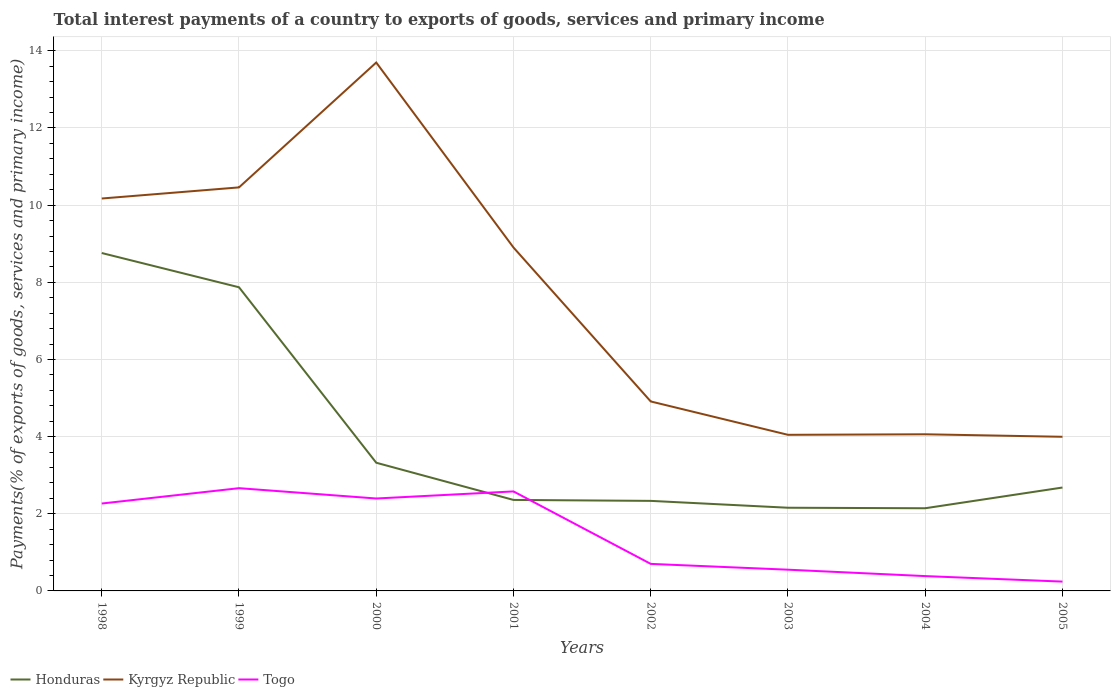How many different coloured lines are there?
Provide a succinct answer. 3. Is the number of lines equal to the number of legend labels?
Provide a succinct answer. Yes. Across all years, what is the maximum total interest payments in Kyrgyz Republic?
Make the answer very short. 4. What is the total total interest payments in Honduras in the graph?
Your answer should be very brief. 0.19. What is the difference between the highest and the second highest total interest payments in Kyrgyz Republic?
Your answer should be compact. 9.7. What is the difference between the highest and the lowest total interest payments in Kyrgyz Republic?
Keep it short and to the point. 4. How many years are there in the graph?
Provide a short and direct response. 8. Are the values on the major ticks of Y-axis written in scientific E-notation?
Make the answer very short. No. Where does the legend appear in the graph?
Give a very brief answer. Bottom left. What is the title of the graph?
Give a very brief answer. Total interest payments of a country to exports of goods, services and primary income. What is the label or title of the X-axis?
Your response must be concise. Years. What is the label or title of the Y-axis?
Your answer should be very brief. Payments(% of exports of goods, services and primary income). What is the Payments(% of exports of goods, services and primary income) of Honduras in 1998?
Your answer should be compact. 8.76. What is the Payments(% of exports of goods, services and primary income) of Kyrgyz Republic in 1998?
Provide a short and direct response. 10.17. What is the Payments(% of exports of goods, services and primary income) of Togo in 1998?
Your answer should be very brief. 2.27. What is the Payments(% of exports of goods, services and primary income) in Honduras in 1999?
Your answer should be very brief. 7.87. What is the Payments(% of exports of goods, services and primary income) of Kyrgyz Republic in 1999?
Your answer should be compact. 10.46. What is the Payments(% of exports of goods, services and primary income) of Togo in 1999?
Keep it short and to the point. 2.66. What is the Payments(% of exports of goods, services and primary income) in Honduras in 2000?
Offer a terse response. 3.32. What is the Payments(% of exports of goods, services and primary income) in Kyrgyz Republic in 2000?
Provide a short and direct response. 13.7. What is the Payments(% of exports of goods, services and primary income) of Togo in 2000?
Make the answer very short. 2.4. What is the Payments(% of exports of goods, services and primary income) of Honduras in 2001?
Your response must be concise. 2.36. What is the Payments(% of exports of goods, services and primary income) of Kyrgyz Republic in 2001?
Make the answer very short. 8.9. What is the Payments(% of exports of goods, services and primary income) of Togo in 2001?
Make the answer very short. 2.58. What is the Payments(% of exports of goods, services and primary income) in Honduras in 2002?
Offer a terse response. 2.33. What is the Payments(% of exports of goods, services and primary income) in Kyrgyz Republic in 2002?
Your response must be concise. 4.91. What is the Payments(% of exports of goods, services and primary income) of Togo in 2002?
Provide a short and direct response. 0.7. What is the Payments(% of exports of goods, services and primary income) in Honduras in 2003?
Offer a terse response. 2.16. What is the Payments(% of exports of goods, services and primary income) of Kyrgyz Republic in 2003?
Keep it short and to the point. 4.05. What is the Payments(% of exports of goods, services and primary income) of Togo in 2003?
Offer a very short reply. 0.55. What is the Payments(% of exports of goods, services and primary income) in Honduras in 2004?
Provide a succinct answer. 2.14. What is the Payments(% of exports of goods, services and primary income) in Kyrgyz Republic in 2004?
Offer a very short reply. 4.06. What is the Payments(% of exports of goods, services and primary income) of Togo in 2004?
Make the answer very short. 0.38. What is the Payments(% of exports of goods, services and primary income) in Honduras in 2005?
Make the answer very short. 2.68. What is the Payments(% of exports of goods, services and primary income) in Kyrgyz Republic in 2005?
Your answer should be very brief. 4. What is the Payments(% of exports of goods, services and primary income) of Togo in 2005?
Provide a succinct answer. 0.24. Across all years, what is the maximum Payments(% of exports of goods, services and primary income) of Honduras?
Provide a short and direct response. 8.76. Across all years, what is the maximum Payments(% of exports of goods, services and primary income) of Kyrgyz Republic?
Keep it short and to the point. 13.7. Across all years, what is the maximum Payments(% of exports of goods, services and primary income) in Togo?
Offer a very short reply. 2.66. Across all years, what is the minimum Payments(% of exports of goods, services and primary income) of Honduras?
Give a very brief answer. 2.14. Across all years, what is the minimum Payments(% of exports of goods, services and primary income) in Kyrgyz Republic?
Make the answer very short. 4. Across all years, what is the minimum Payments(% of exports of goods, services and primary income) in Togo?
Offer a very short reply. 0.24. What is the total Payments(% of exports of goods, services and primary income) of Honduras in the graph?
Offer a very short reply. 31.63. What is the total Payments(% of exports of goods, services and primary income) in Kyrgyz Republic in the graph?
Ensure brevity in your answer.  60.25. What is the total Payments(% of exports of goods, services and primary income) of Togo in the graph?
Your answer should be very brief. 11.78. What is the difference between the Payments(% of exports of goods, services and primary income) of Honduras in 1998 and that in 1999?
Your answer should be very brief. 0.89. What is the difference between the Payments(% of exports of goods, services and primary income) in Kyrgyz Republic in 1998 and that in 1999?
Your response must be concise. -0.29. What is the difference between the Payments(% of exports of goods, services and primary income) of Togo in 1998 and that in 1999?
Provide a succinct answer. -0.4. What is the difference between the Payments(% of exports of goods, services and primary income) of Honduras in 1998 and that in 2000?
Your answer should be compact. 5.44. What is the difference between the Payments(% of exports of goods, services and primary income) of Kyrgyz Republic in 1998 and that in 2000?
Your answer should be very brief. -3.52. What is the difference between the Payments(% of exports of goods, services and primary income) in Togo in 1998 and that in 2000?
Offer a terse response. -0.13. What is the difference between the Payments(% of exports of goods, services and primary income) in Honduras in 1998 and that in 2001?
Your answer should be compact. 6.4. What is the difference between the Payments(% of exports of goods, services and primary income) of Kyrgyz Republic in 1998 and that in 2001?
Your answer should be very brief. 1.27. What is the difference between the Payments(% of exports of goods, services and primary income) of Togo in 1998 and that in 2001?
Make the answer very short. -0.31. What is the difference between the Payments(% of exports of goods, services and primary income) in Honduras in 1998 and that in 2002?
Give a very brief answer. 6.43. What is the difference between the Payments(% of exports of goods, services and primary income) of Kyrgyz Republic in 1998 and that in 2002?
Your answer should be very brief. 5.26. What is the difference between the Payments(% of exports of goods, services and primary income) of Togo in 1998 and that in 2002?
Your answer should be compact. 1.56. What is the difference between the Payments(% of exports of goods, services and primary income) in Honduras in 1998 and that in 2003?
Offer a very short reply. 6.6. What is the difference between the Payments(% of exports of goods, services and primary income) in Kyrgyz Republic in 1998 and that in 2003?
Offer a terse response. 6.13. What is the difference between the Payments(% of exports of goods, services and primary income) in Togo in 1998 and that in 2003?
Your answer should be compact. 1.71. What is the difference between the Payments(% of exports of goods, services and primary income) of Honduras in 1998 and that in 2004?
Keep it short and to the point. 6.62. What is the difference between the Payments(% of exports of goods, services and primary income) in Kyrgyz Republic in 1998 and that in 2004?
Give a very brief answer. 6.11. What is the difference between the Payments(% of exports of goods, services and primary income) of Togo in 1998 and that in 2004?
Provide a short and direct response. 1.88. What is the difference between the Payments(% of exports of goods, services and primary income) of Honduras in 1998 and that in 2005?
Make the answer very short. 6.08. What is the difference between the Payments(% of exports of goods, services and primary income) of Kyrgyz Republic in 1998 and that in 2005?
Provide a short and direct response. 6.18. What is the difference between the Payments(% of exports of goods, services and primary income) of Togo in 1998 and that in 2005?
Provide a short and direct response. 2.02. What is the difference between the Payments(% of exports of goods, services and primary income) of Honduras in 1999 and that in 2000?
Ensure brevity in your answer.  4.55. What is the difference between the Payments(% of exports of goods, services and primary income) of Kyrgyz Republic in 1999 and that in 2000?
Give a very brief answer. -3.24. What is the difference between the Payments(% of exports of goods, services and primary income) of Togo in 1999 and that in 2000?
Your response must be concise. 0.27. What is the difference between the Payments(% of exports of goods, services and primary income) in Honduras in 1999 and that in 2001?
Offer a terse response. 5.51. What is the difference between the Payments(% of exports of goods, services and primary income) in Kyrgyz Republic in 1999 and that in 2001?
Keep it short and to the point. 1.56. What is the difference between the Payments(% of exports of goods, services and primary income) of Togo in 1999 and that in 2001?
Give a very brief answer. 0.08. What is the difference between the Payments(% of exports of goods, services and primary income) in Honduras in 1999 and that in 2002?
Your answer should be compact. 5.54. What is the difference between the Payments(% of exports of goods, services and primary income) of Kyrgyz Republic in 1999 and that in 2002?
Offer a very short reply. 5.55. What is the difference between the Payments(% of exports of goods, services and primary income) in Togo in 1999 and that in 2002?
Your answer should be very brief. 1.96. What is the difference between the Payments(% of exports of goods, services and primary income) in Honduras in 1999 and that in 2003?
Your response must be concise. 5.71. What is the difference between the Payments(% of exports of goods, services and primary income) of Kyrgyz Republic in 1999 and that in 2003?
Make the answer very short. 6.41. What is the difference between the Payments(% of exports of goods, services and primary income) in Togo in 1999 and that in 2003?
Offer a very short reply. 2.11. What is the difference between the Payments(% of exports of goods, services and primary income) of Honduras in 1999 and that in 2004?
Ensure brevity in your answer.  5.73. What is the difference between the Payments(% of exports of goods, services and primary income) in Kyrgyz Republic in 1999 and that in 2004?
Your answer should be very brief. 6.4. What is the difference between the Payments(% of exports of goods, services and primary income) in Togo in 1999 and that in 2004?
Offer a terse response. 2.28. What is the difference between the Payments(% of exports of goods, services and primary income) of Honduras in 1999 and that in 2005?
Offer a terse response. 5.19. What is the difference between the Payments(% of exports of goods, services and primary income) in Kyrgyz Republic in 1999 and that in 2005?
Ensure brevity in your answer.  6.46. What is the difference between the Payments(% of exports of goods, services and primary income) of Togo in 1999 and that in 2005?
Your answer should be very brief. 2.42. What is the difference between the Payments(% of exports of goods, services and primary income) of Honduras in 2000 and that in 2001?
Make the answer very short. 0.96. What is the difference between the Payments(% of exports of goods, services and primary income) in Kyrgyz Republic in 2000 and that in 2001?
Keep it short and to the point. 4.79. What is the difference between the Payments(% of exports of goods, services and primary income) of Togo in 2000 and that in 2001?
Offer a very short reply. -0.18. What is the difference between the Payments(% of exports of goods, services and primary income) in Honduras in 2000 and that in 2002?
Ensure brevity in your answer.  0.99. What is the difference between the Payments(% of exports of goods, services and primary income) of Kyrgyz Republic in 2000 and that in 2002?
Give a very brief answer. 8.79. What is the difference between the Payments(% of exports of goods, services and primary income) of Togo in 2000 and that in 2002?
Provide a succinct answer. 1.7. What is the difference between the Payments(% of exports of goods, services and primary income) of Honduras in 2000 and that in 2003?
Offer a terse response. 1.17. What is the difference between the Payments(% of exports of goods, services and primary income) of Kyrgyz Republic in 2000 and that in 2003?
Offer a terse response. 9.65. What is the difference between the Payments(% of exports of goods, services and primary income) in Togo in 2000 and that in 2003?
Give a very brief answer. 1.85. What is the difference between the Payments(% of exports of goods, services and primary income) in Honduras in 2000 and that in 2004?
Keep it short and to the point. 1.18. What is the difference between the Payments(% of exports of goods, services and primary income) in Kyrgyz Republic in 2000 and that in 2004?
Your answer should be very brief. 9.64. What is the difference between the Payments(% of exports of goods, services and primary income) of Togo in 2000 and that in 2004?
Provide a succinct answer. 2.01. What is the difference between the Payments(% of exports of goods, services and primary income) in Honduras in 2000 and that in 2005?
Keep it short and to the point. 0.64. What is the difference between the Payments(% of exports of goods, services and primary income) of Kyrgyz Republic in 2000 and that in 2005?
Your answer should be very brief. 9.7. What is the difference between the Payments(% of exports of goods, services and primary income) of Togo in 2000 and that in 2005?
Make the answer very short. 2.15. What is the difference between the Payments(% of exports of goods, services and primary income) of Honduras in 2001 and that in 2002?
Ensure brevity in your answer.  0.02. What is the difference between the Payments(% of exports of goods, services and primary income) of Kyrgyz Republic in 2001 and that in 2002?
Ensure brevity in your answer.  3.99. What is the difference between the Payments(% of exports of goods, services and primary income) of Togo in 2001 and that in 2002?
Your answer should be compact. 1.88. What is the difference between the Payments(% of exports of goods, services and primary income) of Honduras in 2001 and that in 2003?
Offer a very short reply. 0.2. What is the difference between the Payments(% of exports of goods, services and primary income) in Kyrgyz Republic in 2001 and that in 2003?
Provide a short and direct response. 4.86. What is the difference between the Payments(% of exports of goods, services and primary income) of Togo in 2001 and that in 2003?
Offer a very short reply. 2.03. What is the difference between the Payments(% of exports of goods, services and primary income) of Honduras in 2001 and that in 2004?
Offer a very short reply. 0.22. What is the difference between the Payments(% of exports of goods, services and primary income) of Kyrgyz Republic in 2001 and that in 2004?
Provide a succinct answer. 4.84. What is the difference between the Payments(% of exports of goods, services and primary income) in Togo in 2001 and that in 2004?
Keep it short and to the point. 2.19. What is the difference between the Payments(% of exports of goods, services and primary income) of Honduras in 2001 and that in 2005?
Your answer should be compact. -0.32. What is the difference between the Payments(% of exports of goods, services and primary income) of Kyrgyz Republic in 2001 and that in 2005?
Ensure brevity in your answer.  4.91. What is the difference between the Payments(% of exports of goods, services and primary income) of Togo in 2001 and that in 2005?
Ensure brevity in your answer.  2.34. What is the difference between the Payments(% of exports of goods, services and primary income) in Honduras in 2002 and that in 2003?
Offer a terse response. 0.18. What is the difference between the Payments(% of exports of goods, services and primary income) in Kyrgyz Republic in 2002 and that in 2003?
Give a very brief answer. 0.86. What is the difference between the Payments(% of exports of goods, services and primary income) of Togo in 2002 and that in 2003?
Offer a very short reply. 0.15. What is the difference between the Payments(% of exports of goods, services and primary income) in Honduras in 2002 and that in 2004?
Provide a succinct answer. 0.19. What is the difference between the Payments(% of exports of goods, services and primary income) of Kyrgyz Republic in 2002 and that in 2004?
Your response must be concise. 0.85. What is the difference between the Payments(% of exports of goods, services and primary income) of Togo in 2002 and that in 2004?
Your response must be concise. 0.32. What is the difference between the Payments(% of exports of goods, services and primary income) of Honduras in 2002 and that in 2005?
Provide a succinct answer. -0.35. What is the difference between the Payments(% of exports of goods, services and primary income) of Kyrgyz Republic in 2002 and that in 2005?
Offer a terse response. 0.92. What is the difference between the Payments(% of exports of goods, services and primary income) in Togo in 2002 and that in 2005?
Give a very brief answer. 0.46. What is the difference between the Payments(% of exports of goods, services and primary income) of Honduras in 2003 and that in 2004?
Offer a terse response. 0.01. What is the difference between the Payments(% of exports of goods, services and primary income) of Kyrgyz Republic in 2003 and that in 2004?
Your answer should be compact. -0.01. What is the difference between the Payments(% of exports of goods, services and primary income) of Togo in 2003 and that in 2004?
Offer a very short reply. 0.17. What is the difference between the Payments(% of exports of goods, services and primary income) of Honduras in 2003 and that in 2005?
Your answer should be compact. -0.52. What is the difference between the Payments(% of exports of goods, services and primary income) in Kyrgyz Republic in 2003 and that in 2005?
Keep it short and to the point. 0.05. What is the difference between the Payments(% of exports of goods, services and primary income) in Togo in 2003 and that in 2005?
Your response must be concise. 0.31. What is the difference between the Payments(% of exports of goods, services and primary income) in Honduras in 2004 and that in 2005?
Provide a succinct answer. -0.54. What is the difference between the Payments(% of exports of goods, services and primary income) in Kyrgyz Republic in 2004 and that in 2005?
Provide a succinct answer. 0.06. What is the difference between the Payments(% of exports of goods, services and primary income) of Togo in 2004 and that in 2005?
Provide a succinct answer. 0.14. What is the difference between the Payments(% of exports of goods, services and primary income) in Honduras in 1998 and the Payments(% of exports of goods, services and primary income) in Kyrgyz Republic in 1999?
Offer a terse response. -1.7. What is the difference between the Payments(% of exports of goods, services and primary income) of Honduras in 1998 and the Payments(% of exports of goods, services and primary income) of Togo in 1999?
Your answer should be compact. 6.1. What is the difference between the Payments(% of exports of goods, services and primary income) in Kyrgyz Republic in 1998 and the Payments(% of exports of goods, services and primary income) in Togo in 1999?
Give a very brief answer. 7.51. What is the difference between the Payments(% of exports of goods, services and primary income) in Honduras in 1998 and the Payments(% of exports of goods, services and primary income) in Kyrgyz Republic in 2000?
Your answer should be compact. -4.94. What is the difference between the Payments(% of exports of goods, services and primary income) in Honduras in 1998 and the Payments(% of exports of goods, services and primary income) in Togo in 2000?
Provide a short and direct response. 6.36. What is the difference between the Payments(% of exports of goods, services and primary income) of Kyrgyz Republic in 1998 and the Payments(% of exports of goods, services and primary income) of Togo in 2000?
Ensure brevity in your answer.  7.78. What is the difference between the Payments(% of exports of goods, services and primary income) in Honduras in 1998 and the Payments(% of exports of goods, services and primary income) in Kyrgyz Republic in 2001?
Your answer should be compact. -0.14. What is the difference between the Payments(% of exports of goods, services and primary income) of Honduras in 1998 and the Payments(% of exports of goods, services and primary income) of Togo in 2001?
Keep it short and to the point. 6.18. What is the difference between the Payments(% of exports of goods, services and primary income) of Kyrgyz Republic in 1998 and the Payments(% of exports of goods, services and primary income) of Togo in 2001?
Offer a terse response. 7.59. What is the difference between the Payments(% of exports of goods, services and primary income) of Honduras in 1998 and the Payments(% of exports of goods, services and primary income) of Kyrgyz Republic in 2002?
Offer a terse response. 3.85. What is the difference between the Payments(% of exports of goods, services and primary income) of Honduras in 1998 and the Payments(% of exports of goods, services and primary income) of Togo in 2002?
Your answer should be compact. 8.06. What is the difference between the Payments(% of exports of goods, services and primary income) in Kyrgyz Republic in 1998 and the Payments(% of exports of goods, services and primary income) in Togo in 2002?
Your answer should be compact. 9.47. What is the difference between the Payments(% of exports of goods, services and primary income) in Honduras in 1998 and the Payments(% of exports of goods, services and primary income) in Kyrgyz Republic in 2003?
Your response must be concise. 4.71. What is the difference between the Payments(% of exports of goods, services and primary income) in Honduras in 1998 and the Payments(% of exports of goods, services and primary income) in Togo in 2003?
Offer a very short reply. 8.21. What is the difference between the Payments(% of exports of goods, services and primary income) in Kyrgyz Republic in 1998 and the Payments(% of exports of goods, services and primary income) in Togo in 2003?
Your answer should be compact. 9.62. What is the difference between the Payments(% of exports of goods, services and primary income) in Honduras in 1998 and the Payments(% of exports of goods, services and primary income) in Kyrgyz Republic in 2004?
Ensure brevity in your answer.  4.7. What is the difference between the Payments(% of exports of goods, services and primary income) in Honduras in 1998 and the Payments(% of exports of goods, services and primary income) in Togo in 2004?
Offer a terse response. 8.37. What is the difference between the Payments(% of exports of goods, services and primary income) in Kyrgyz Republic in 1998 and the Payments(% of exports of goods, services and primary income) in Togo in 2004?
Your response must be concise. 9.79. What is the difference between the Payments(% of exports of goods, services and primary income) in Honduras in 1998 and the Payments(% of exports of goods, services and primary income) in Kyrgyz Republic in 2005?
Your answer should be very brief. 4.76. What is the difference between the Payments(% of exports of goods, services and primary income) in Honduras in 1998 and the Payments(% of exports of goods, services and primary income) in Togo in 2005?
Your answer should be very brief. 8.52. What is the difference between the Payments(% of exports of goods, services and primary income) of Kyrgyz Republic in 1998 and the Payments(% of exports of goods, services and primary income) of Togo in 2005?
Offer a very short reply. 9.93. What is the difference between the Payments(% of exports of goods, services and primary income) of Honduras in 1999 and the Payments(% of exports of goods, services and primary income) of Kyrgyz Republic in 2000?
Your answer should be compact. -5.83. What is the difference between the Payments(% of exports of goods, services and primary income) in Honduras in 1999 and the Payments(% of exports of goods, services and primary income) in Togo in 2000?
Give a very brief answer. 5.48. What is the difference between the Payments(% of exports of goods, services and primary income) in Kyrgyz Republic in 1999 and the Payments(% of exports of goods, services and primary income) in Togo in 2000?
Offer a very short reply. 8.06. What is the difference between the Payments(% of exports of goods, services and primary income) in Honduras in 1999 and the Payments(% of exports of goods, services and primary income) in Kyrgyz Republic in 2001?
Provide a succinct answer. -1.03. What is the difference between the Payments(% of exports of goods, services and primary income) in Honduras in 1999 and the Payments(% of exports of goods, services and primary income) in Togo in 2001?
Keep it short and to the point. 5.29. What is the difference between the Payments(% of exports of goods, services and primary income) of Kyrgyz Republic in 1999 and the Payments(% of exports of goods, services and primary income) of Togo in 2001?
Your answer should be compact. 7.88. What is the difference between the Payments(% of exports of goods, services and primary income) in Honduras in 1999 and the Payments(% of exports of goods, services and primary income) in Kyrgyz Republic in 2002?
Your response must be concise. 2.96. What is the difference between the Payments(% of exports of goods, services and primary income) in Honduras in 1999 and the Payments(% of exports of goods, services and primary income) in Togo in 2002?
Provide a succinct answer. 7.17. What is the difference between the Payments(% of exports of goods, services and primary income) of Kyrgyz Republic in 1999 and the Payments(% of exports of goods, services and primary income) of Togo in 2002?
Ensure brevity in your answer.  9.76. What is the difference between the Payments(% of exports of goods, services and primary income) in Honduras in 1999 and the Payments(% of exports of goods, services and primary income) in Kyrgyz Republic in 2003?
Keep it short and to the point. 3.82. What is the difference between the Payments(% of exports of goods, services and primary income) of Honduras in 1999 and the Payments(% of exports of goods, services and primary income) of Togo in 2003?
Give a very brief answer. 7.32. What is the difference between the Payments(% of exports of goods, services and primary income) of Kyrgyz Republic in 1999 and the Payments(% of exports of goods, services and primary income) of Togo in 2003?
Make the answer very short. 9.91. What is the difference between the Payments(% of exports of goods, services and primary income) in Honduras in 1999 and the Payments(% of exports of goods, services and primary income) in Kyrgyz Republic in 2004?
Keep it short and to the point. 3.81. What is the difference between the Payments(% of exports of goods, services and primary income) in Honduras in 1999 and the Payments(% of exports of goods, services and primary income) in Togo in 2004?
Make the answer very short. 7.49. What is the difference between the Payments(% of exports of goods, services and primary income) of Kyrgyz Republic in 1999 and the Payments(% of exports of goods, services and primary income) of Togo in 2004?
Offer a very short reply. 10.08. What is the difference between the Payments(% of exports of goods, services and primary income) of Honduras in 1999 and the Payments(% of exports of goods, services and primary income) of Kyrgyz Republic in 2005?
Give a very brief answer. 3.88. What is the difference between the Payments(% of exports of goods, services and primary income) in Honduras in 1999 and the Payments(% of exports of goods, services and primary income) in Togo in 2005?
Your answer should be very brief. 7.63. What is the difference between the Payments(% of exports of goods, services and primary income) of Kyrgyz Republic in 1999 and the Payments(% of exports of goods, services and primary income) of Togo in 2005?
Keep it short and to the point. 10.22. What is the difference between the Payments(% of exports of goods, services and primary income) in Honduras in 2000 and the Payments(% of exports of goods, services and primary income) in Kyrgyz Republic in 2001?
Offer a terse response. -5.58. What is the difference between the Payments(% of exports of goods, services and primary income) of Honduras in 2000 and the Payments(% of exports of goods, services and primary income) of Togo in 2001?
Your answer should be compact. 0.74. What is the difference between the Payments(% of exports of goods, services and primary income) of Kyrgyz Republic in 2000 and the Payments(% of exports of goods, services and primary income) of Togo in 2001?
Keep it short and to the point. 11.12. What is the difference between the Payments(% of exports of goods, services and primary income) of Honduras in 2000 and the Payments(% of exports of goods, services and primary income) of Kyrgyz Republic in 2002?
Your answer should be very brief. -1.59. What is the difference between the Payments(% of exports of goods, services and primary income) of Honduras in 2000 and the Payments(% of exports of goods, services and primary income) of Togo in 2002?
Your answer should be very brief. 2.62. What is the difference between the Payments(% of exports of goods, services and primary income) in Kyrgyz Republic in 2000 and the Payments(% of exports of goods, services and primary income) in Togo in 2002?
Keep it short and to the point. 13. What is the difference between the Payments(% of exports of goods, services and primary income) in Honduras in 2000 and the Payments(% of exports of goods, services and primary income) in Kyrgyz Republic in 2003?
Your response must be concise. -0.72. What is the difference between the Payments(% of exports of goods, services and primary income) of Honduras in 2000 and the Payments(% of exports of goods, services and primary income) of Togo in 2003?
Your answer should be compact. 2.77. What is the difference between the Payments(% of exports of goods, services and primary income) of Kyrgyz Republic in 2000 and the Payments(% of exports of goods, services and primary income) of Togo in 2003?
Your answer should be compact. 13.15. What is the difference between the Payments(% of exports of goods, services and primary income) in Honduras in 2000 and the Payments(% of exports of goods, services and primary income) in Kyrgyz Republic in 2004?
Ensure brevity in your answer.  -0.74. What is the difference between the Payments(% of exports of goods, services and primary income) of Honduras in 2000 and the Payments(% of exports of goods, services and primary income) of Togo in 2004?
Your answer should be compact. 2.94. What is the difference between the Payments(% of exports of goods, services and primary income) in Kyrgyz Republic in 2000 and the Payments(% of exports of goods, services and primary income) in Togo in 2004?
Provide a succinct answer. 13.31. What is the difference between the Payments(% of exports of goods, services and primary income) of Honduras in 2000 and the Payments(% of exports of goods, services and primary income) of Kyrgyz Republic in 2005?
Make the answer very short. -0.67. What is the difference between the Payments(% of exports of goods, services and primary income) in Honduras in 2000 and the Payments(% of exports of goods, services and primary income) in Togo in 2005?
Provide a short and direct response. 3.08. What is the difference between the Payments(% of exports of goods, services and primary income) of Kyrgyz Republic in 2000 and the Payments(% of exports of goods, services and primary income) of Togo in 2005?
Give a very brief answer. 13.46. What is the difference between the Payments(% of exports of goods, services and primary income) in Honduras in 2001 and the Payments(% of exports of goods, services and primary income) in Kyrgyz Republic in 2002?
Ensure brevity in your answer.  -2.55. What is the difference between the Payments(% of exports of goods, services and primary income) in Honduras in 2001 and the Payments(% of exports of goods, services and primary income) in Togo in 2002?
Provide a short and direct response. 1.66. What is the difference between the Payments(% of exports of goods, services and primary income) in Kyrgyz Republic in 2001 and the Payments(% of exports of goods, services and primary income) in Togo in 2002?
Your answer should be very brief. 8.2. What is the difference between the Payments(% of exports of goods, services and primary income) of Honduras in 2001 and the Payments(% of exports of goods, services and primary income) of Kyrgyz Republic in 2003?
Give a very brief answer. -1.69. What is the difference between the Payments(% of exports of goods, services and primary income) of Honduras in 2001 and the Payments(% of exports of goods, services and primary income) of Togo in 2003?
Provide a short and direct response. 1.81. What is the difference between the Payments(% of exports of goods, services and primary income) in Kyrgyz Republic in 2001 and the Payments(% of exports of goods, services and primary income) in Togo in 2003?
Ensure brevity in your answer.  8.35. What is the difference between the Payments(% of exports of goods, services and primary income) of Honduras in 2001 and the Payments(% of exports of goods, services and primary income) of Kyrgyz Republic in 2004?
Provide a short and direct response. -1.7. What is the difference between the Payments(% of exports of goods, services and primary income) in Honduras in 2001 and the Payments(% of exports of goods, services and primary income) in Togo in 2004?
Your answer should be very brief. 1.97. What is the difference between the Payments(% of exports of goods, services and primary income) in Kyrgyz Republic in 2001 and the Payments(% of exports of goods, services and primary income) in Togo in 2004?
Your response must be concise. 8.52. What is the difference between the Payments(% of exports of goods, services and primary income) in Honduras in 2001 and the Payments(% of exports of goods, services and primary income) in Kyrgyz Republic in 2005?
Give a very brief answer. -1.64. What is the difference between the Payments(% of exports of goods, services and primary income) in Honduras in 2001 and the Payments(% of exports of goods, services and primary income) in Togo in 2005?
Your answer should be compact. 2.12. What is the difference between the Payments(% of exports of goods, services and primary income) of Kyrgyz Republic in 2001 and the Payments(% of exports of goods, services and primary income) of Togo in 2005?
Your answer should be very brief. 8.66. What is the difference between the Payments(% of exports of goods, services and primary income) of Honduras in 2002 and the Payments(% of exports of goods, services and primary income) of Kyrgyz Republic in 2003?
Your answer should be very brief. -1.71. What is the difference between the Payments(% of exports of goods, services and primary income) of Honduras in 2002 and the Payments(% of exports of goods, services and primary income) of Togo in 2003?
Keep it short and to the point. 1.78. What is the difference between the Payments(% of exports of goods, services and primary income) in Kyrgyz Republic in 2002 and the Payments(% of exports of goods, services and primary income) in Togo in 2003?
Provide a short and direct response. 4.36. What is the difference between the Payments(% of exports of goods, services and primary income) in Honduras in 2002 and the Payments(% of exports of goods, services and primary income) in Kyrgyz Republic in 2004?
Keep it short and to the point. -1.73. What is the difference between the Payments(% of exports of goods, services and primary income) in Honduras in 2002 and the Payments(% of exports of goods, services and primary income) in Togo in 2004?
Keep it short and to the point. 1.95. What is the difference between the Payments(% of exports of goods, services and primary income) in Kyrgyz Republic in 2002 and the Payments(% of exports of goods, services and primary income) in Togo in 2004?
Your response must be concise. 4.53. What is the difference between the Payments(% of exports of goods, services and primary income) in Honduras in 2002 and the Payments(% of exports of goods, services and primary income) in Kyrgyz Republic in 2005?
Offer a terse response. -1.66. What is the difference between the Payments(% of exports of goods, services and primary income) of Honduras in 2002 and the Payments(% of exports of goods, services and primary income) of Togo in 2005?
Provide a succinct answer. 2.09. What is the difference between the Payments(% of exports of goods, services and primary income) in Kyrgyz Republic in 2002 and the Payments(% of exports of goods, services and primary income) in Togo in 2005?
Your response must be concise. 4.67. What is the difference between the Payments(% of exports of goods, services and primary income) of Honduras in 2003 and the Payments(% of exports of goods, services and primary income) of Kyrgyz Republic in 2004?
Make the answer very short. -1.9. What is the difference between the Payments(% of exports of goods, services and primary income) in Honduras in 2003 and the Payments(% of exports of goods, services and primary income) in Togo in 2004?
Provide a succinct answer. 1.77. What is the difference between the Payments(% of exports of goods, services and primary income) in Kyrgyz Republic in 2003 and the Payments(% of exports of goods, services and primary income) in Togo in 2004?
Give a very brief answer. 3.66. What is the difference between the Payments(% of exports of goods, services and primary income) of Honduras in 2003 and the Payments(% of exports of goods, services and primary income) of Kyrgyz Republic in 2005?
Your answer should be compact. -1.84. What is the difference between the Payments(% of exports of goods, services and primary income) in Honduras in 2003 and the Payments(% of exports of goods, services and primary income) in Togo in 2005?
Offer a terse response. 1.91. What is the difference between the Payments(% of exports of goods, services and primary income) in Kyrgyz Republic in 2003 and the Payments(% of exports of goods, services and primary income) in Togo in 2005?
Give a very brief answer. 3.8. What is the difference between the Payments(% of exports of goods, services and primary income) in Honduras in 2004 and the Payments(% of exports of goods, services and primary income) in Kyrgyz Republic in 2005?
Offer a very short reply. -1.85. What is the difference between the Payments(% of exports of goods, services and primary income) of Honduras in 2004 and the Payments(% of exports of goods, services and primary income) of Togo in 2005?
Offer a terse response. 1.9. What is the difference between the Payments(% of exports of goods, services and primary income) of Kyrgyz Republic in 2004 and the Payments(% of exports of goods, services and primary income) of Togo in 2005?
Your response must be concise. 3.82. What is the average Payments(% of exports of goods, services and primary income) in Honduras per year?
Provide a short and direct response. 3.95. What is the average Payments(% of exports of goods, services and primary income) of Kyrgyz Republic per year?
Make the answer very short. 7.53. What is the average Payments(% of exports of goods, services and primary income) of Togo per year?
Provide a short and direct response. 1.47. In the year 1998, what is the difference between the Payments(% of exports of goods, services and primary income) of Honduras and Payments(% of exports of goods, services and primary income) of Kyrgyz Republic?
Make the answer very short. -1.41. In the year 1998, what is the difference between the Payments(% of exports of goods, services and primary income) in Honduras and Payments(% of exports of goods, services and primary income) in Togo?
Make the answer very short. 6.49. In the year 1998, what is the difference between the Payments(% of exports of goods, services and primary income) in Kyrgyz Republic and Payments(% of exports of goods, services and primary income) in Togo?
Offer a terse response. 7.91. In the year 1999, what is the difference between the Payments(% of exports of goods, services and primary income) in Honduras and Payments(% of exports of goods, services and primary income) in Kyrgyz Republic?
Provide a short and direct response. -2.59. In the year 1999, what is the difference between the Payments(% of exports of goods, services and primary income) in Honduras and Payments(% of exports of goods, services and primary income) in Togo?
Make the answer very short. 5.21. In the year 1999, what is the difference between the Payments(% of exports of goods, services and primary income) of Kyrgyz Republic and Payments(% of exports of goods, services and primary income) of Togo?
Offer a terse response. 7.8. In the year 2000, what is the difference between the Payments(% of exports of goods, services and primary income) of Honduras and Payments(% of exports of goods, services and primary income) of Kyrgyz Republic?
Your answer should be very brief. -10.37. In the year 2000, what is the difference between the Payments(% of exports of goods, services and primary income) of Honduras and Payments(% of exports of goods, services and primary income) of Togo?
Offer a terse response. 0.93. In the year 2000, what is the difference between the Payments(% of exports of goods, services and primary income) of Kyrgyz Republic and Payments(% of exports of goods, services and primary income) of Togo?
Your answer should be very brief. 11.3. In the year 2001, what is the difference between the Payments(% of exports of goods, services and primary income) in Honduras and Payments(% of exports of goods, services and primary income) in Kyrgyz Republic?
Your response must be concise. -6.54. In the year 2001, what is the difference between the Payments(% of exports of goods, services and primary income) of Honduras and Payments(% of exports of goods, services and primary income) of Togo?
Offer a very short reply. -0.22. In the year 2001, what is the difference between the Payments(% of exports of goods, services and primary income) in Kyrgyz Republic and Payments(% of exports of goods, services and primary income) in Togo?
Offer a very short reply. 6.32. In the year 2002, what is the difference between the Payments(% of exports of goods, services and primary income) of Honduras and Payments(% of exports of goods, services and primary income) of Kyrgyz Republic?
Your response must be concise. -2.58. In the year 2002, what is the difference between the Payments(% of exports of goods, services and primary income) in Honduras and Payments(% of exports of goods, services and primary income) in Togo?
Offer a very short reply. 1.63. In the year 2002, what is the difference between the Payments(% of exports of goods, services and primary income) in Kyrgyz Republic and Payments(% of exports of goods, services and primary income) in Togo?
Offer a terse response. 4.21. In the year 2003, what is the difference between the Payments(% of exports of goods, services and primary income) of Honduras and Payments(% of exports of goods, services and primary income) of Kyrgyz Republic?
Your response must be concise. -1.89. In the year 2003, what is the difference between the Payments(% of exports of goods, services and primary income) of Honduras and Payments(% of exports of goods, services and primary income) of Togo?
Keep it short and to the point. 1.61. In the year 2003, what is the difference between the Payments(% of exports of goods, services and primary income) of Kyrgyz Republic and Payments(% of exports of goods, services and primary income) of Togo?
Your response must be concise. 3.5. In the year 2004, what is the difference between the Payments(% of exports of goods, services and primary income) in Honduras and Payments(% of exports of goods, services and primary income) in Kyrgyz Republic?
Keep it short and to the point. -1.92. In the year 2004, what is the difference between the Payments(% of exports of goods, services and primary income) of Honduras and Payments(% of exports of goods, services and primary income) of Togo?
Keep it short and to the point. 1.76. In the year 2004, what is the difference between the Payments(% of exports of goods, services and primary income) in Kyrgyz Republic and Payments(% of exports of goods, services and primary income) in Togo?
Offer a terse response. 3.68. In the year 2005, what is the difference between the Payments(% of exports of goods, services and primary income) of Honduras and Payments(% of exports of goods, services and primary income) of Kyrgyz Republic?
Your response must be concise. -1.32. In the year 2005, what is the difference between the Payments(% of exports of goods, services and primary income) in Honduras and Payments(% of exports of goods, services and primary income) in Togo?
Your response must be concise. 2.44. In the year 2005, what is the difference between the Payments(% of exports of goods, services and primary income) of Kyrgyz Republic and Payments(% of exports of goods, services and primary income) of Togo?
Your answer should be very brief. 3.75. What is the ratio of the Payments(% of exports of goods, services and primary income) of Honduras in 1998 to that in 1999?
Offer a very short reply. 1.11. What is the ratio of the Payments(% of exports of goods, services and primary income) in Kyrgyz Republic in 1998 to that in 1999?
Keep it short and to the point. 0.97. What is the ratio of the Payments(% of exports of goods, services and primary income) of Togo in 1998 to that in 1999?
Provide a succinct answer. 0.85. What is the ratio of the Payments(% of exports of goods, services and primary income) in Honduras in 1998 to that in 2000?
Keep it short and to the point. 2.64. What is the ratio of the Payments(% of exports of goods, services and primary income) of Kyrgyz Republic in 1998 to that in 2000?
Your response must be concise. 0.74. What is the ratio of the Payments(% of exports of goods, services and primary income) of Togo in 1998 to that in 2000?
Your response must be concise. 0.95. What is the ratio of the Payments(% of exports of goods, services and primary income) in Honduras in 1998 to that in 2001?
Provide a short and direct response. 3.71. What is the ratio of the Payments(% of exports of goods, services and primary income) of Kyrgyz Republic in 1998 to that in 2001?
Offer a very short reply. 1.14. What is the ratio of the Payments(% of exports of goods, services and primary income) of Togo in 1998 to that in 2001?
Ensure brevity in your answer.  0.88. What is the ratio of the Payments(% of exports of goods, services and primary income) of Honduras in 1998 to that in 2002?
Provide a short and direct response. 3.75. What is the ratio of the Payments(% of exports of goods, services and primary income) in Kyrgyz Republic in 1998 to that in 2002?
Your answer should be compact. 2.07. What is the ratio of the Payments(% of exports of goods, services and primary income) of Togo in 1998 to that in 2002?
Give a very brief answer. 3.23. What is the ratio of the Payments(% of exports of goods, services and primary income) in Honduras in 1998 to that in 2003?
Give a very brief answer. 4.06. What is the ratio of the Payments(% of exports of goods, services and primary income) of Kyrgyz Republic in 1998 to that in 2003?
Your response must be concise. 2.51. What is the ratio of the Payments(% of exports of goods, services and primary income) in Togo in 1998 to that in 2003?
Provide a short and direct response. 4.12. What is the ratio of the Payments(% of exports of goods, services and primary income) of Honduras in 1998 to that in 2004?
Offer a terse response. 4.09. What is the ratio of the Payments(% of exports of goods, services and primary income) of Kyrgyz Republic in 1998 to that in 2004?
Offer a terse response. 2.51. What is the ratio of the Payments(% of exports of goods, services and primary income) in Togo in 1998 to that in 2004?
Give a very brief answer. 5.89. What is the ratio of the Payments(% of exports of goods, services and primary income) of Honduras in 1998 to that in 2005?
Your answer should be very brief. 3.27. What is the ratio of the Payments(% of exports of goods, services and primary income) in Kyrgyz Republic in 1998 to that in 2005?
Your answer should be compact. 2.55. What is the ratio of the Payments(% of exports of goods, services and primary income) of Togo in 1998 to that in 2005?
Offer a very short reply. 9.37. What is the ratio of the Payments(% of exports of goods, services and primary income) in Honduras in 1999 to that in 2000?
Provide a succinct answer. 2.37. What is the ratio of the Payments(% of exports of goods, services and primary income) of Kyrgyz Republic in 1999 to that in 2000?
Ensure brevity in your answer.  0.76. What is the ratio of the Payments(% of exports of goods, services and primary income) in Togo in 1999 to that in 2000?
Your answer should be compact. 1.11. What is the ratio of the Payments(% of exports of goods, services and primary income) of Honduras in 1999 to that in 2001?
Your response must be concise. 3.34. What is the ratio of the Payments(% of exports of goods, services and primary income) in Kyrgyz Republic in 1999 to that in 2001?
Your answer should be compact. 1.18. What is the ratio of the Payments(% of exports of goods, services and primary income) of Togo in 1999 to that in 2001?
Your answer should be compact. 1.03. What is the ratio of the Payments(% of exports of goods, services and primary income) in Honduras in 1999 to that in 2002?
Provide a succinct answer. 3.37. What is the ratio of the Payments(% of exports of goods, services and primary income) of Kyrgyz Republic in 1999 to that in 2002?
Your answer should be very brief. 2.13. What is the ratio of the Payments(% of exports of goods, services and primary income) in Togo in 1999 to that in 2002?
Your answer should be compact. 3.8. What is the ratio of the Payments(% of exports of goods, services and primary income) in Honduras in 1999 to that in 2003?
Your answer should be compact. 3.65. What is the ratio of the Payments(% of exports of goods, services and primary income) in Kyrgyz Republic in 1999 to that in 2003?
Keep it short and to the point. 2.58. What is the ratio of the Payments(% of exports of goods, services and primary income) in Togo in 1999 to that in 2003?
Make the answer very short. 4.84. What is the ratio of the Payments(% of exports of goods, services and primary income) in Honduras in 1999 to that in 2004?
Provide a succinct answer. 3.67. What is the ratio of the Payments(% of exports of goods, services and primary income) in Kyrgyz Republic in 1999 to that in 2004?
Give a very brief answer. 2.58. What is the ratio of the Payments(% of exports of goods, services and primary income) of Togo in 1999 to that in 2004?
Offer a terse response. 6.93. What is the ratio of the Payments(% of exports of goods, services and primary income) of Honduras in 1999 to that in 2005?
Your response must be concise. 2.94. What is the ratio of the Payments(% of exports of goods, services and primary income) of Kyrgyz Republic in 1999 to that in 2005?
Offer a terse response. 2.62. What is the ratio of the Payments(% of exports of goods, services and primary income) in Togo in 1999 to that in 2005?
Provide a short and direct response. 11.02. What is the ratio of the Payments(% of exports of goods, services and primary income) of Honduras in 2000 to that in 2001?
Ensure brevity in your answer.  1.41. What is the ratio of the Payments(% of exports of goods, services and primary income) of Kyrgyz Republic in 2000 to that in 2001?
Offer a terse response. 1.54. What is the ratio of the Payments(% of exports of goods, services and primary income) of Togo in 2000 to that in 2001?
Give a very brief answer. 0.93. What is the ratio of the Payments(% of exports of goods, services and primary income) in Honduras in 2000 to that in 2002?
Ensure brevity in your answer.  1.42. What is the ratio of the Payments(% of exports of goods, services and primary income) of Kyrgyz Republic in 2000 to that in 2002?
Your answer should be compact. 2.79. What is the ratio of the Payments(% of exports of goods, services and primary income) of Togo in 2000 to that in 2002?
Your response must be concise. 3.42. What is the ratio of the Payments(% of exports of goods, services and primary income) of Honduras in 2000 to that in 2003?
Your answer should be compact. 1.54. What is the ratio of the Payments(% of exports of goods, services and primary income) of Kyrgyz Republic in 2000 to that in 2003?
Offer a very short reply. 3.38. What is the ratio of the Payments(% of exports of goods, services and primary income) in Togo in 2000 to that in 2003?
Make the answer very short. 4.35. What is the ratio of the Payments(% of exports of goods, services and primary income) in Honduras in 2000 to that in 2004?
Your answer should be compact. 1.55. What is the ratio of the Payments(% of exports of goods, services and primary income) in Kyrgyz Republic in 2000 to that in 2004?
Your response must be concise. 3.37. What is the ratio of the Payments(% of exports of goods, services and primary income) in Togo in 2000 to that in 2004?
Your answer should be compact. 6.23. What is the ratio of the Payments(% of exports of goods, services and primary income) of Honduras in 2000 to that in 2005?
Make the answer very short. 1.24. What is the ratio of the Payments(% of exports of goods, services and primary income) of Kyrgyz Republic in 2000 to that in 2005?
Your answer should be compact. 3.43. What is the ratio of the Payments(% of exports of goods, services and primary income) in Togo in 2000 to that in 2005?
Ensure brevity in your answer.  9.91. What is the ratio of the Payments(% of exports of goods, services and primary income) of Honduras in 2001 to that in 2002?
Your answer should be compact. 1.01. What is the ratio of the Payments(% of exports of goods, services and primary income) of Kyrgyz Republic in 2001 to that in 2002?
Your response must be concise. 1.81. What is the ratio of the Payments(% of exports of goods, services and primary income) of Togo in 2001 to that in 2002?
Provide a short and direct response. 3.68. What is the ratio of the Payments(% of exports of goods, services and primary income) in Honduras in 2001 to that in 2003?
Give a very brief answer. 1.09. What is the ratio of the Payments(% of exports of goods, services and primary income) in Kyrgyz Republic in 2001 to that in 2003?
Ensure brevity in your answer.  2.2. What is the ratio of the Payments(% of exports of goods, services and primary income) in Togo in 2001 to that in 2003?
Ensure brevity in your answer.  4.69. What is the ratio of the Payments(% of exports of goods, services and primary income) of Honduras in 2001 to that in 2004?
Your answer should be compact. 1.1. What is the ratio of the Payments(% of exports of goods, services and primary income) of Kyrgyz Republic in 2001 to that in 2004?
Make the answer very short. 2.19. What is the ratio of the Payments(% of exports of goods, services and primary income) of Togo in 2001 to that in 2004?
Give a very brief answer. 6.71. What is the ratio of the Payments(% of exports of goods, services and primary income) in Honduras in 2001 to that in 2005?
Keep it short and to the point. 0.88. What is the ratio of the Payments(% of exports of goods, services and primary income) in Kyrgyz Republic in 2001 to that in 2005?
Your answer should be very brief. 2.23. What is the ratio of the Payments(% of exports of goods, services and primary income) of Togo in 2001 to that in 2005?
Give a very brief answer. 10.67. What is the ratio of the Payments(% of exports of goods, services and primary income) in Honduras in 2002 to that in 2003?
Provide a short and direct response. 1.08. What is the ratio of the Payments(% of exports of goods, services and primary income) of Kyrgyz Republic in 2002 to that in 2003?
Your answer should be very brief. 1.21. What is the ratio of the Payments(% of exports of goods, services and primary income) in Togo in 2002 to that in 2003?
Ensure brevity in your answer.  1.27. What is the ratio of the Payments(% of exports of goods, services and primary income) in Honduras in 2002 to that in 2004?
Keep it short and to the point. 1.09. What is the ratio of the Payments(% of exports of goods, services and primary income) in Kyrgyz Republic in 2002 to that in 2004?
Your answer should be very brief. 1.21. What is the ratio of the Payments(% of exports of goods, services and primary income) in Togo in 2002 to that in 2004?
Offer a terse response. 1.82. What is the ratio of the Payments(% of exports of goods, services and primary income) of Honduras in 2002 to that in 2005?
Ensure brevity in your answer.  0.87. What is the ratio of the Payments(% of exports of goods, services and primary income) in Kyrgyz Republic in 2002 to that in 2005?
Your answer should be very brief. 1.23. What is the ratio of the Payments(% of exports of goods, services and primary income) of Kyrgyz Republic in 2003 to that in 2004?
Your answer should be very brief. 1. What is the ratio of the Payments(% of exports of goods, services and primary income) in Togo in 2003 to that in 2004?
Provide a succinct answer. 1.43. What is the ratio of the Payments(% of exports of goods, services and primary income) of Honduras in 2003 to that in 2005?
Offer a terse response. 0.8. What is the ratio of the Payments(% of exports of goods, services and primary income) of Kyrgyz Republic in 2003 to that in 2005?
Offer a very short reply. 1.01. What is the ratio of the Payments(% of exports of goods, services and primary income) in Togo in 2003 to that in 2005?
Ensure brevity in your answer.  2.28. What is the ratio of the Payments(% of exports of goods, services and primary income) in Honduras in 2004 to that in 2005?
Your response must be concise. 0.8. What is the ratio of the Payments(% of exports of goods, services and primary income) of Kyrgyz Republic in 2004 to that in 2005?
Offer a terse response. 1.02. What is the ratio of the Payments(% of exports of goods, services and primary income) in Togo in 2004 to that in 2005?
Your response must be concise. 1.59. What is the difference between the highest and the second highest Payments(% of exports of goods, services and primary income) in Honduras?
Your answer should be very brief. 0.89. What is the difference between the highest and the second highest Payments(% of exports of goods, services and primary income) in Kyrgyz Republic?
Provide a succinct answer. 3.24. What is the difference between the highest and the second highest Payments(% of exports of goods, services and primary income) in Togo?
Your answer should be compact. 0.08. What is the difference between the highest and the lowest Payments(% of exports of goods, services and primary income) of Honduras?
Provide a short and direct response. 6.62. What is the difference between the highest and the lowest Payments(% of exports of goods, services and primary income) of Kyrgyz Republic?
Offer a very short reply. 9.7. What is the difference between the highest and the lowest Payments(% of exports of goods, services and primary income) in Togo?
Give a very brief answer. 2.42. 